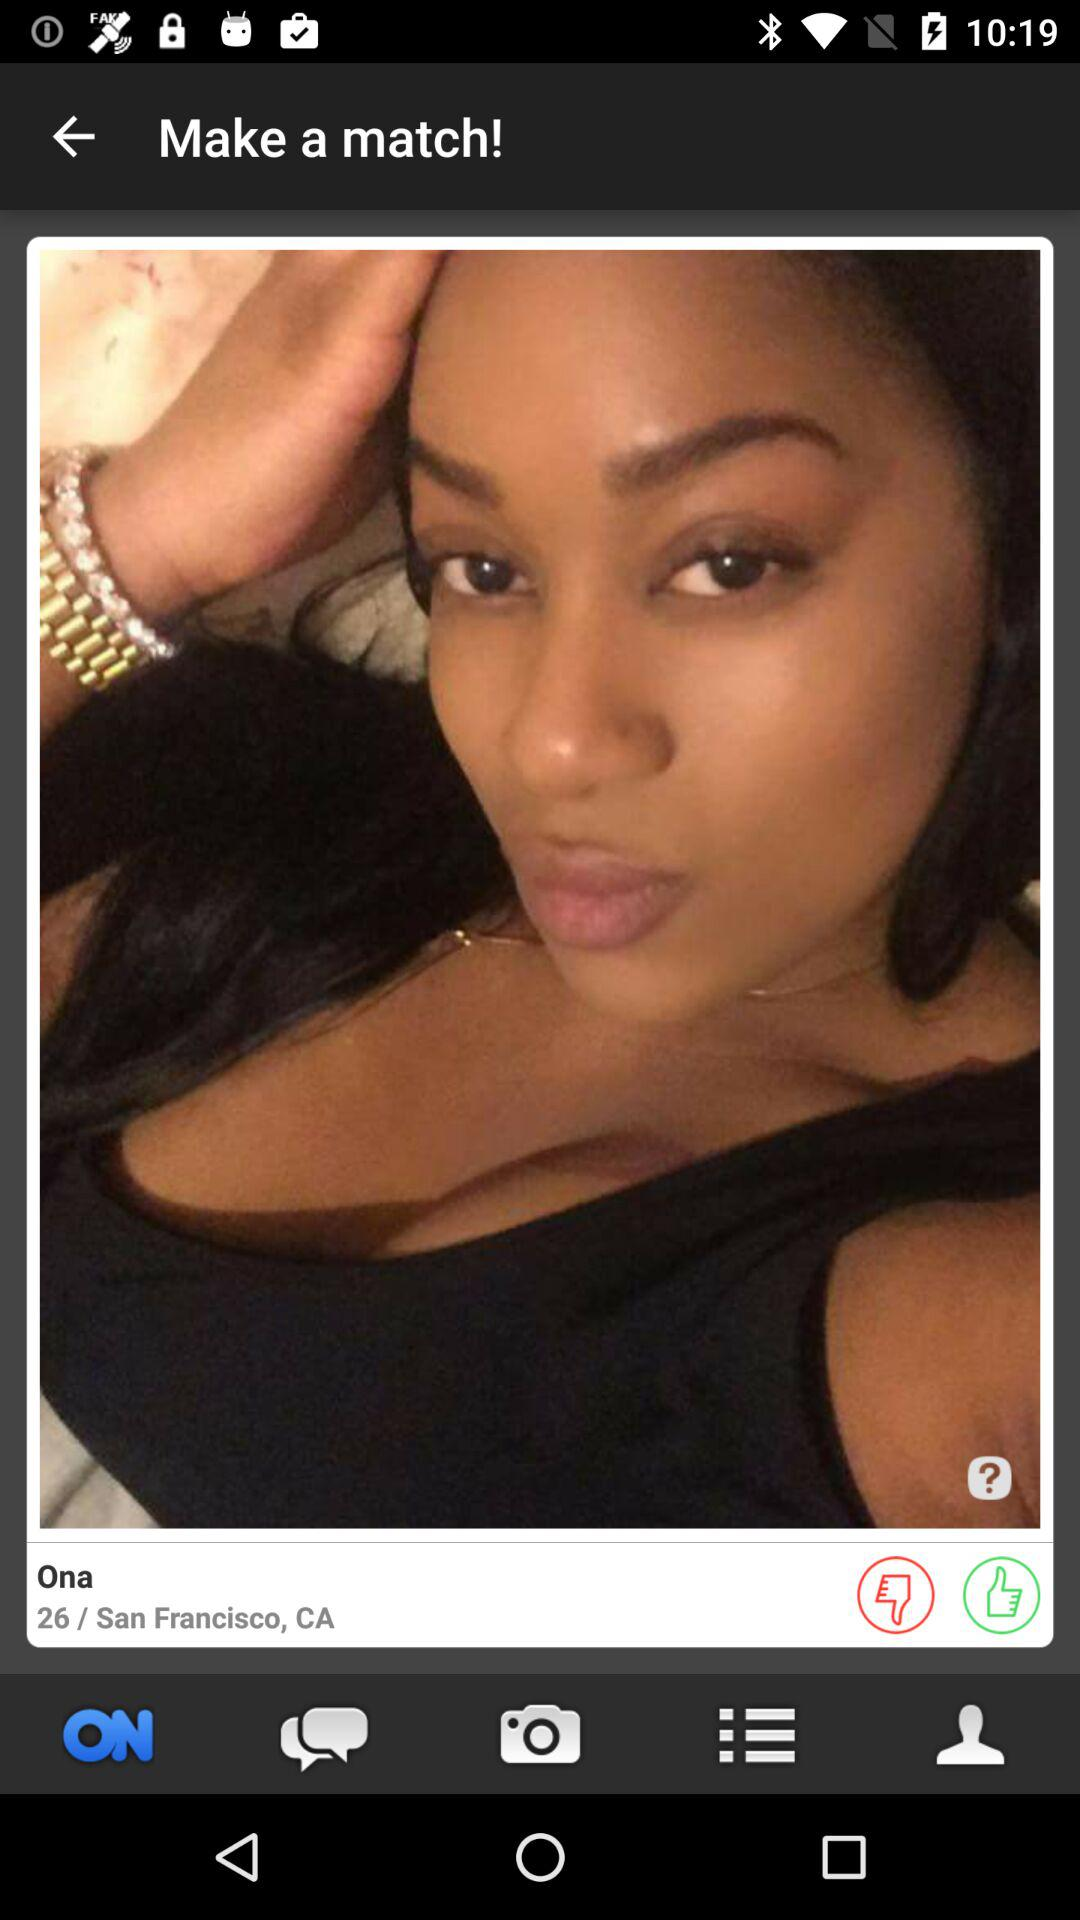What is the location of Ona? The location is San Francisco, CA. 